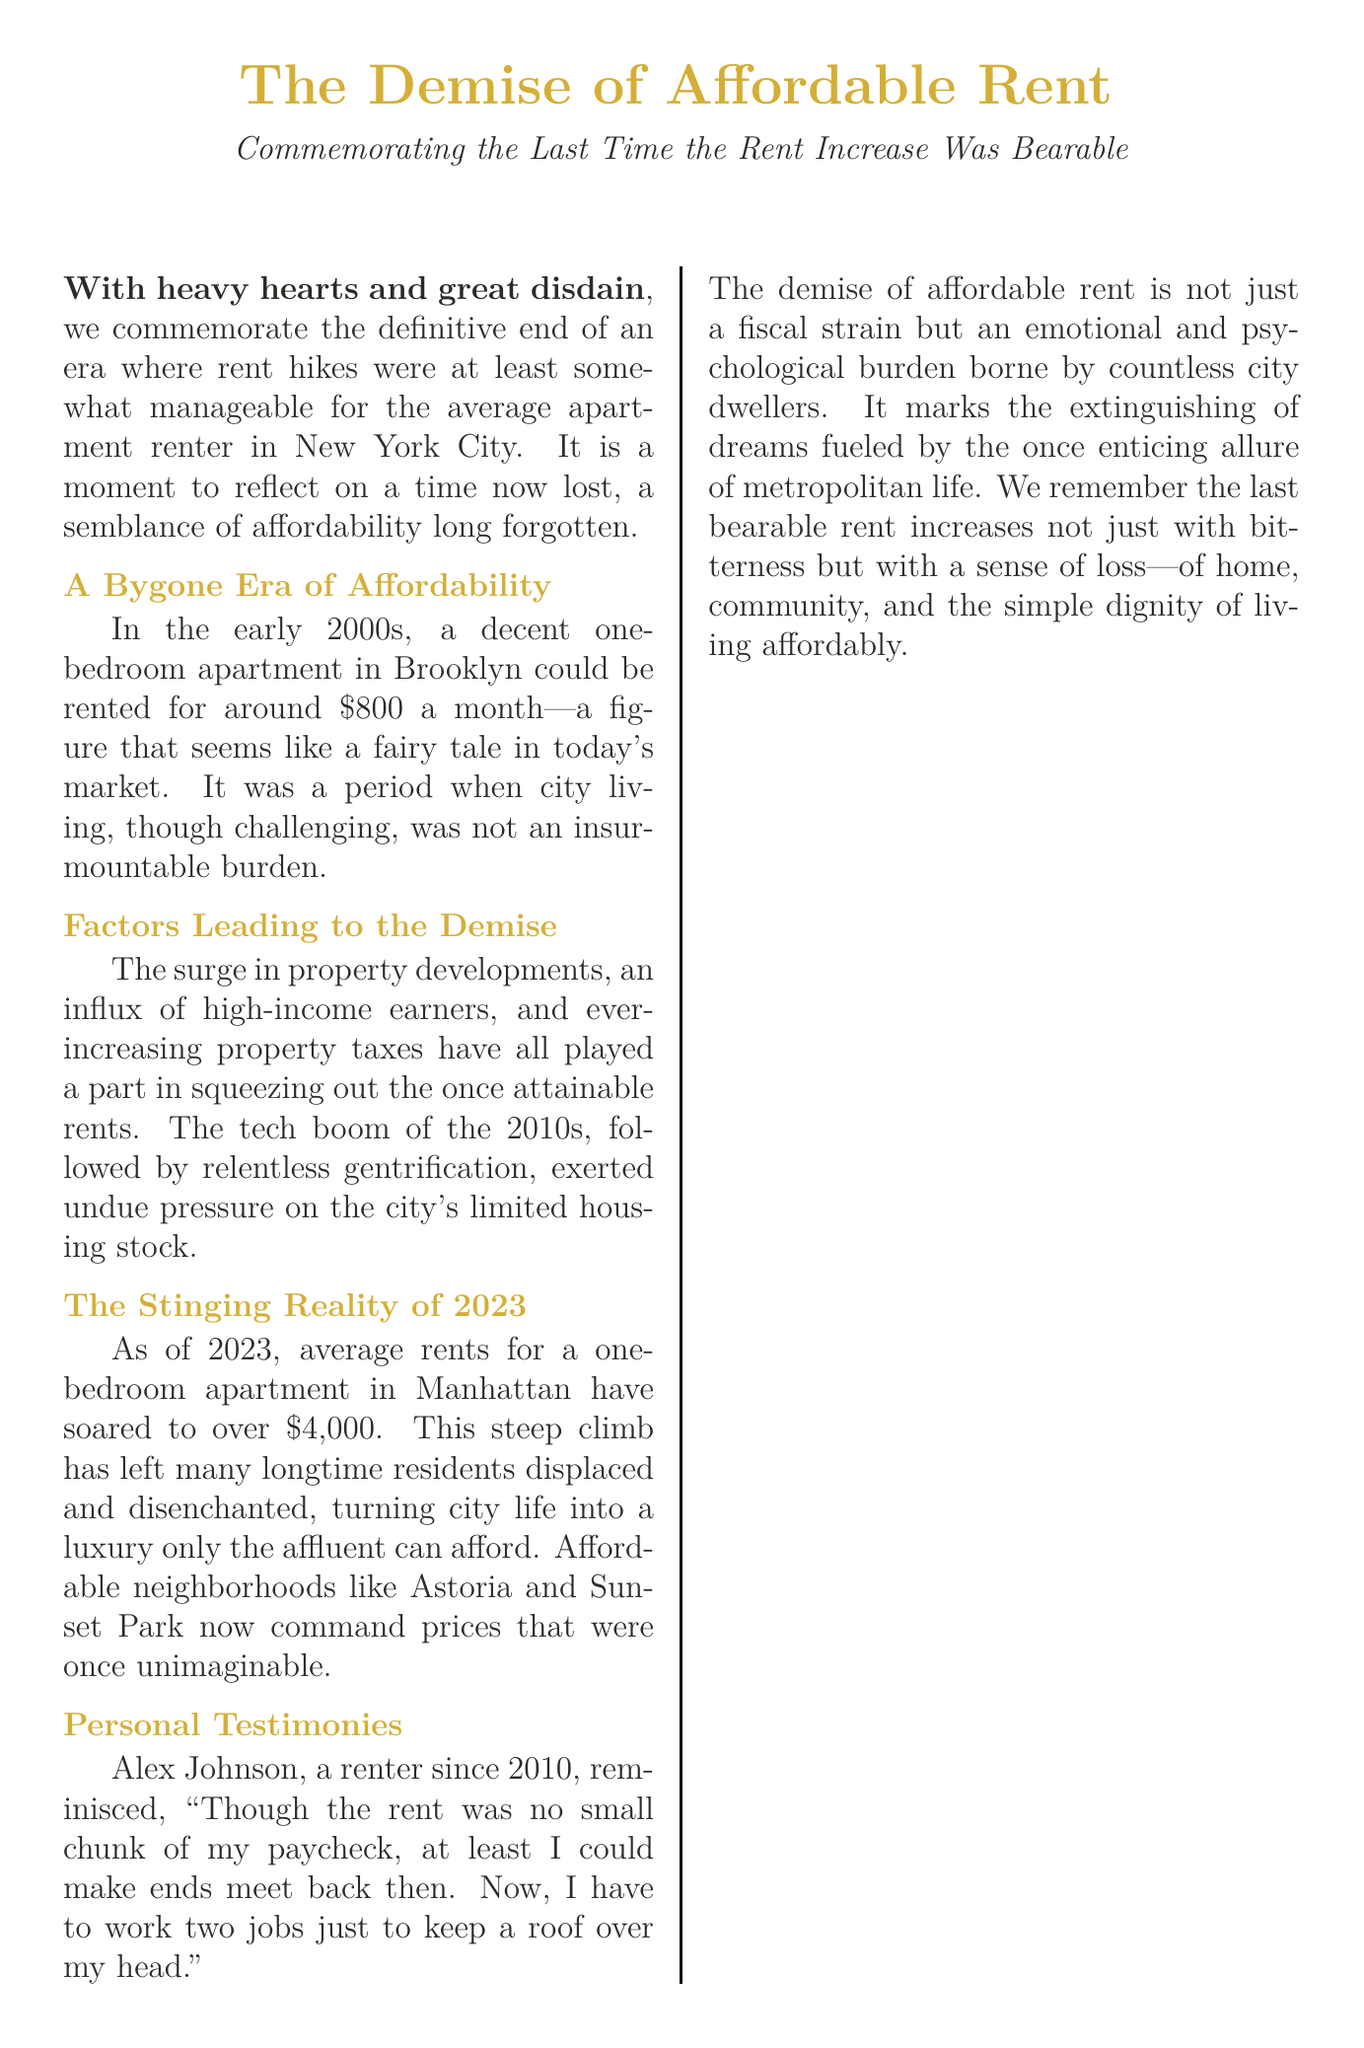what year did affordable rent begin to decline? The document states that the era of affordable rent was lost starting in the early 2000s, marking the beginning of its decline.
Answer: early 2000s what was the rent for a one-bedroom apartment in Brooklyn in the early 2000s? The document mentions that a decent one-bedroom apartment in Brooklyn could be rented for around $800 a month during that time.
Answer: $800 how much do average rents for a one-bedroom apartment in Manhattan exceed in 2023? According to the document, average rents for a one-bedroom apartment in Manhattan have soared to over $4,000.
Answer: over $4,000 who is quoted in the document regarding the burden of current rents? The document includes a personal testimony from Alex Johnson, who discusses the difficulties of making ends meet.
Answer: Alex Johnson what major factors contributed to the demise of affordable rent? The document lists several factors such as the surge in property developments, high-income earners, and increasing property taxes.
Answer: property developments, high-income earners, property taxes what type of document is this? The document serves as an obituary commemorating the end of affordable rent, often reflecting on loss and nostalgia.
Answer: obituary what year range is mentioned in the memorial section? The memorial section notes the years during which affordable rent existed, from 2000 to 2023.
Answer: 2000 - 2023 what does the document suggest about the emotional impact of rising rents? The document highlights that the demise of affordable rent is not merely a fiscal issue but also an emotional and psychological burden for many renters.
Answer: emotional and psychological burden 